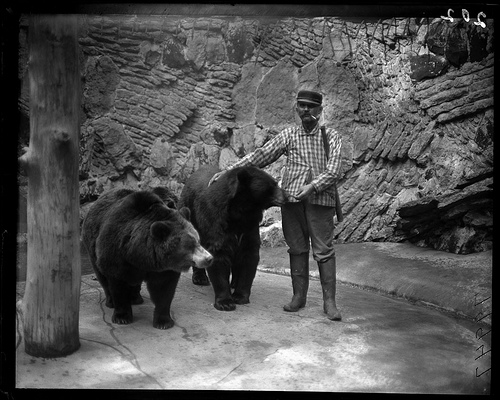Can you tell me about the man standing with the bears? The man in the image, who is standing confidently beside two large bears, is likely a trainer or keeper. He's dressed in a plaid shirt and boots, which suggest a practical outfit for handling such large animals. His posture indicates familiarity and ease around the bears, highlighting a possibly strong understanding and relationship with them. What does the environment suggest about where this photo was taken? The stone walls and rugged setting imply that this photo might have been taken in an enclosured area, possibly part of a zoo or wildlife sanctuary. The construction suggests early to mid-20th century design, aiming to provide a semi-natural environment for the bears. 